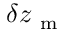Convert formula to latex. <formula><loc_0><loc_0><loc_500><loc_500>\delta z _ { m }</formula> 